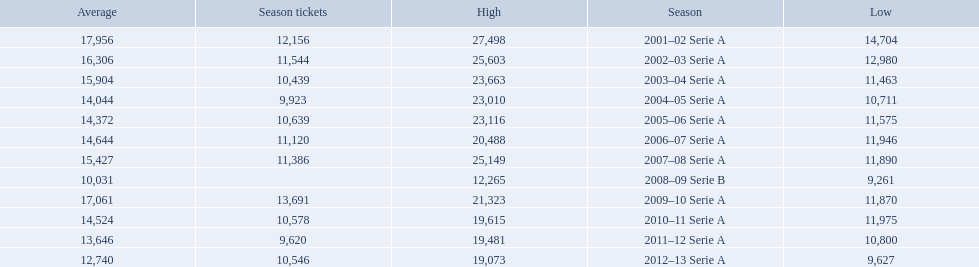When were all of the seasons? 2001–02 Serie A, 2002–03 Serie A, 2003–04 Serie A, 2004–05 Serie A, 2005–06 Serie A, 2006–07 Serie A, 2007–08 Serie A, 2008–09 Serie B, 2009–10 Serie A, 2010–11 Serie A, 2011–12 Serie A, 2012–13 Serie A. How many tickets were sold? 12,156, 11,544, 10,439, 9,923, 10,639, 11,120, 11,386, , 13,691, 10,578, 9,620, 10,546. What about just during the 2007 season? 11,386. 